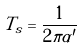Convert formula to latex. <formula><loc_0><loc_0><loc_500><loc_500>T _ { s } = \frac { 1 } { 2 \pi \alpha ^ { \prime } }</formula> 